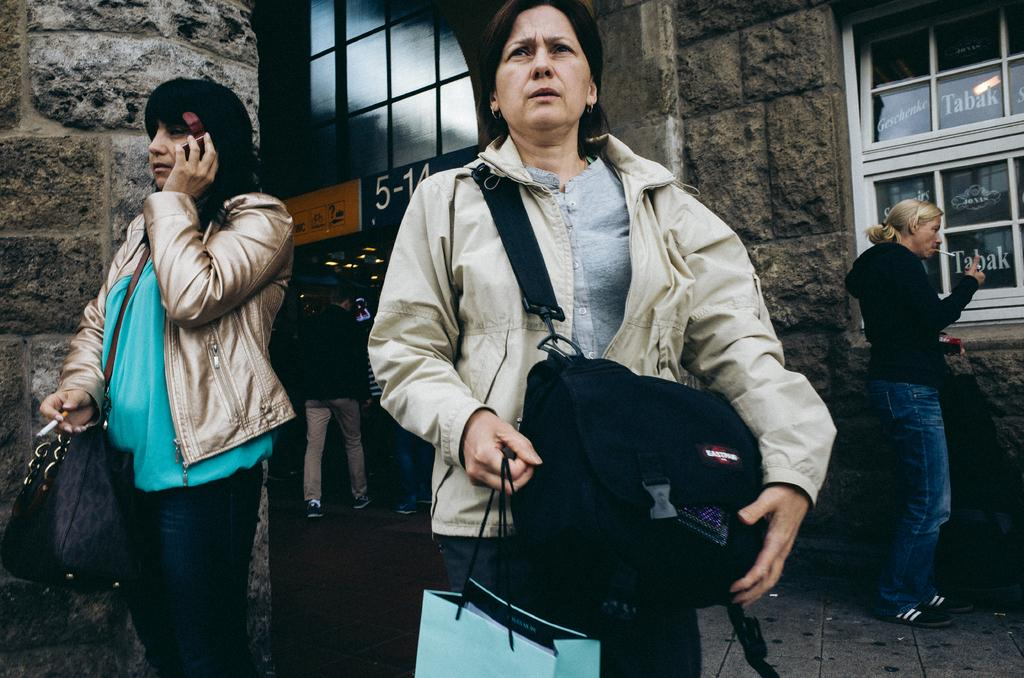How many people are in the image? There are people in the image, but the exact number is not specified. What is one person wearing in the image? One person is wearing a bag. What is another person holding in the image? One person is holding a cigar. What is another person holding in the image? One person is holding an object. What is another person wearing in the image? Another person is wearing a jacket. What is another person wearing in the image? Another person is wearing a bag. What can be seen in the background of the image? There are glass windows and a wall in the background. What type of bun is being used as a decoration on the rail in the image? There is no rail or bun present in the image. What type of amusement can be seen in the image? There is no amusement depicted in the image. 